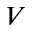Convert formula to latex. <formula><loc_0><loc_0><loc_500><loc_500>V</formula> 